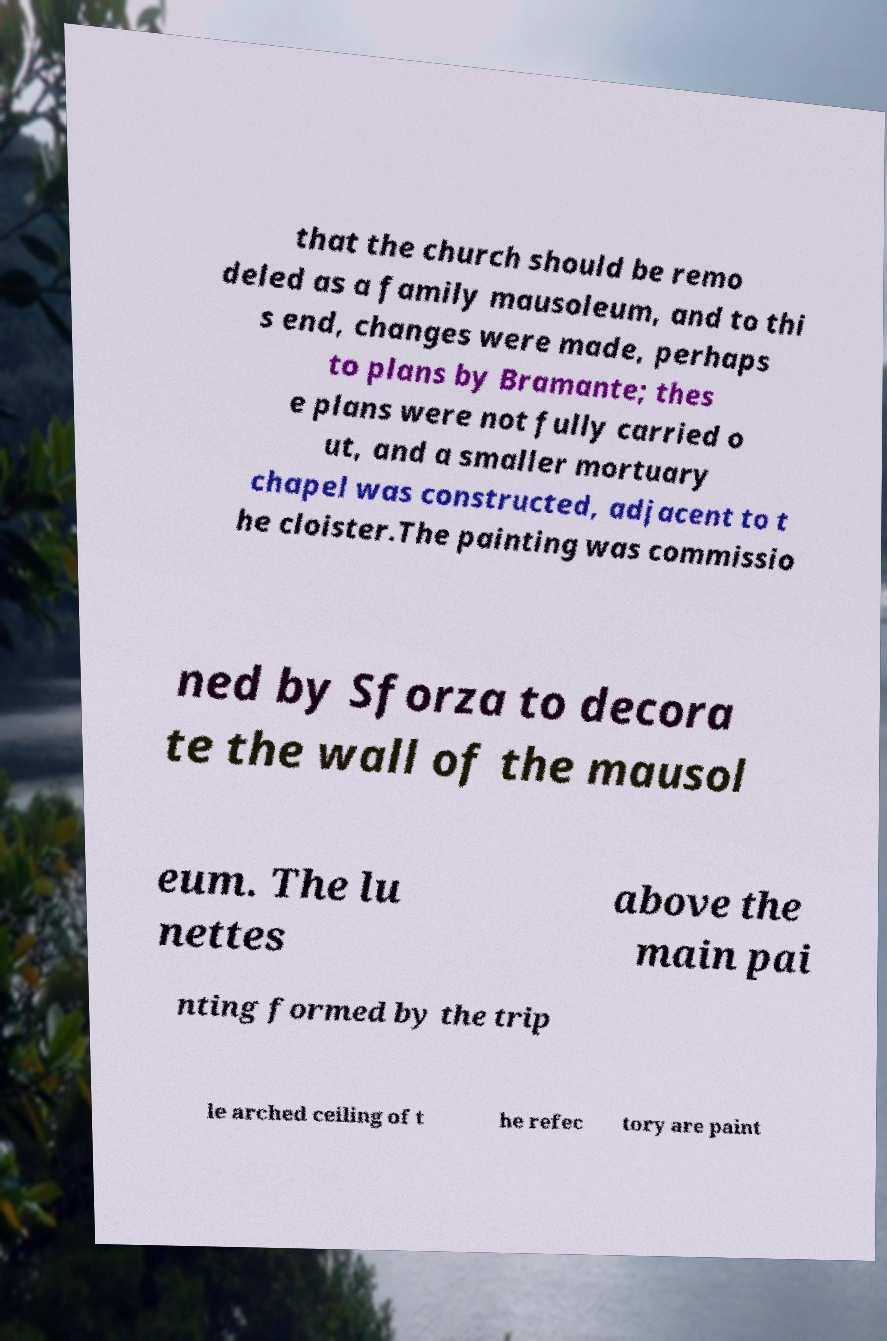What messages or text are displayed in this image? I need them in a readable, typed format. that the church should be remo deled as a family mausoleum, and to thi s end, changes were made, perhaps to plans by Bramante; thes e plans were not fully carried o ut, and a smaller mortuary chapel was constructed, adjacent to t he cloister.The painting was commissio ned by Sforza to decora te the wall of the mausol eum. The lu nettes above the main pai nting formed by the trip le arched ceiling of t he refec tory are paint 